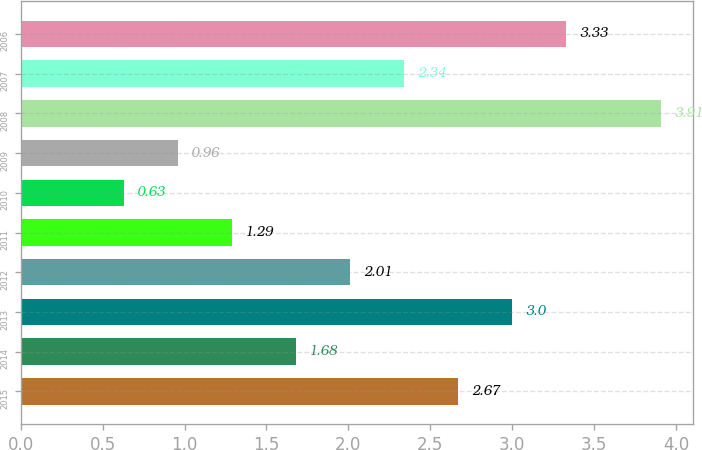Convert chart to OTSL. <chart><loc_0><loc_0><loc_500><loc_500><bar_chart><fcel>2015<fcel>2014<fcel>2013<fcel>2012<fcel>2011<fcel>2010<fcel>2009<fcel>2008<fcel>2007<fcel>2006<nl><fcel>2.67<fcel>1.68<fcel>3<fcel>2.01<fcel>1.29<fcel>0.63<fcel>0.96<fcel>3.91<fcel>2.34<fcel>3.33<nl></chart> 